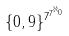Convert formula to latex. <formula><loc_0><loc_0><loc_500><loc_500>\{ 0 , 9 \} ^ { 7 ^ { 7 ^ { \aleph _ { 0 } } } }</formula> 